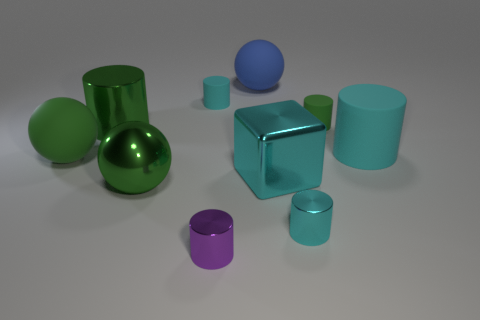Do the big matte cylinder and the metallic block have the same color?
Make the answer very short. Yes. There is a matte thing in front of the big cyan rubber object; is it the same color as the large metallic cylinder?
Make the answer very short. Yes. How many metallic objects are either cyan spheres or blue spheres?
Provide a succinct answer. 0. What color is the large block that is made of the same material as the small purple thing?
Keep it short and to the point. Cyan. How many balls are big cyan rubber objects or small purple things?
Keep it short and to the point. 0. What number of objects are either rubber spheres or tiny cylinders that are right of the big cube?
Give a very brief answer. 4. Are there any small brown rubber objects?
Offer a very short reply. No. What number of small shiny cylinders are the same color as the cube?
Make the answer very short. 1. What material is the big cylinder that is the same color as the metallic sphere?
Keep it short and to the point. Metal. There is a rubber sphere that is behind the cyan rubber cylinder on the left side of the small cyan metal thing; what size is it?
Give a very brief answer. Large. 